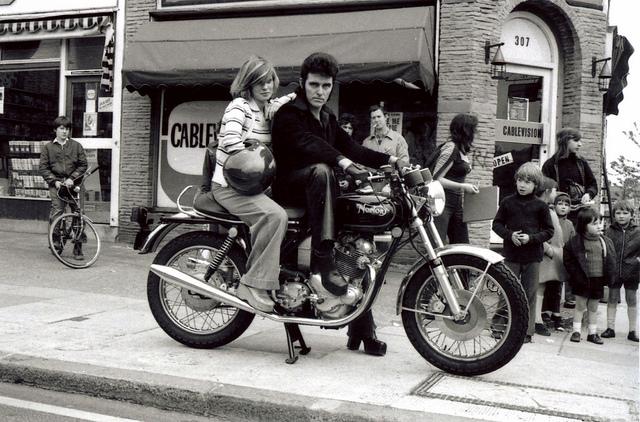Is the motorcycle in motion?
Answer briefly. No. What is number on the building?
Be succinct. 307. How many girls are on bikes?
Short answer required. 1. How many people are on the motorcycle?
Be succinct. 2. 